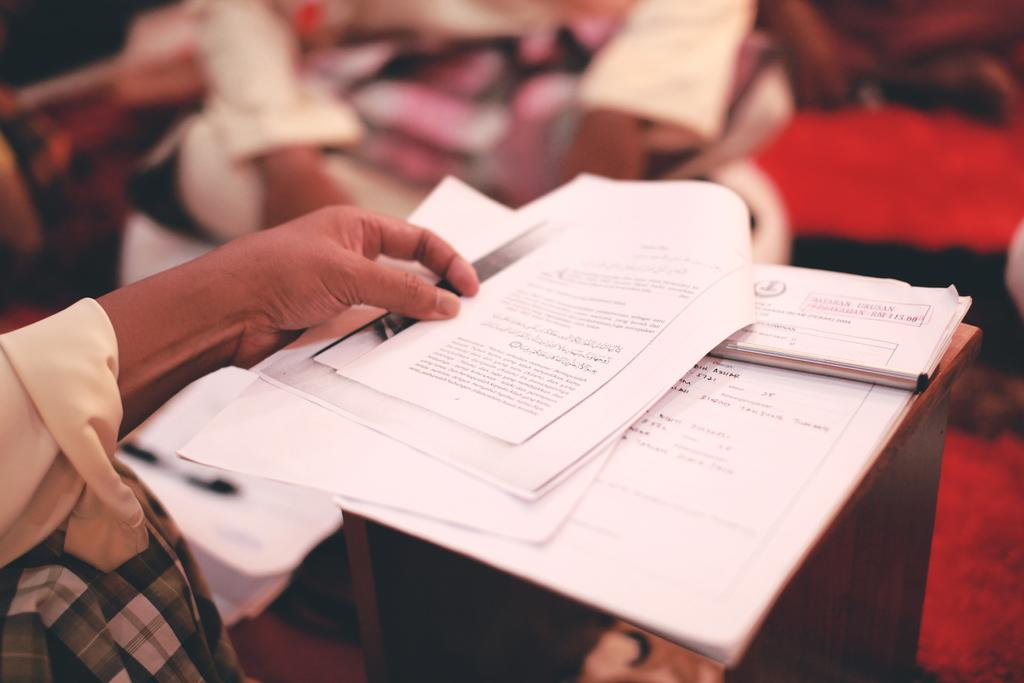Who or what is the main subject in the image? There is a person in the image. What is the person holding in the image? The person is holding papers. Can you describe the wooden object in the image? There are papers on a wooden object, but its specific type is not mentioned. What can be seen in the background of the image? There are blurred things in the background of the image. How many sisters are visible in the image? There is no mention of sisters in the image, so it is not possible to answer this question. 